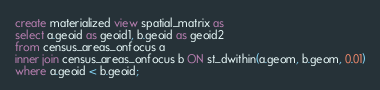Convert code to text. <code><loc_0><loc_0><loc_500><loc_500><_SQL_>create materialized view spatial_matrix as
select a.geoid as geoid1, b.geoid as geoid2
from census_areas_onfocus a
inner join census_areas_onfocus b ON st_dwithin(a.geom, b.geom, 0.01)
where a.geoid < b.geoid;
</code> 